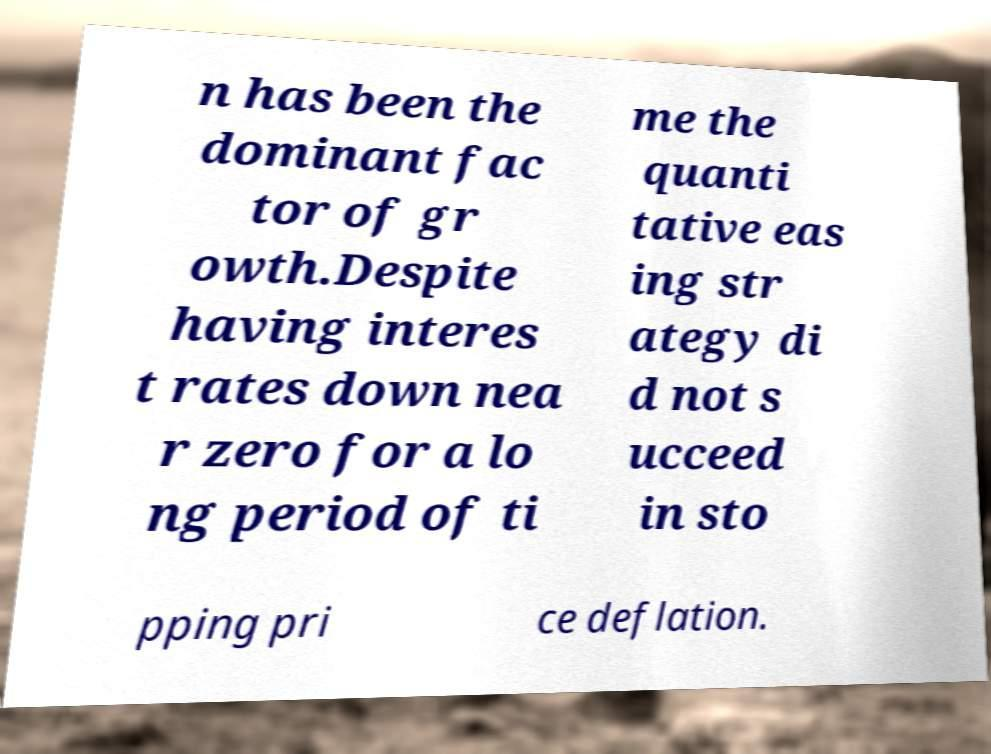Please identify and transcribe the text found in this image. n has been the dominant fac tor of gr owth.Despite having interes t rates down nea r zero for a lo ng period of ti me the quanti tative eas ing str ategy di d not s ucceed in sto pping pri ce deflation. 